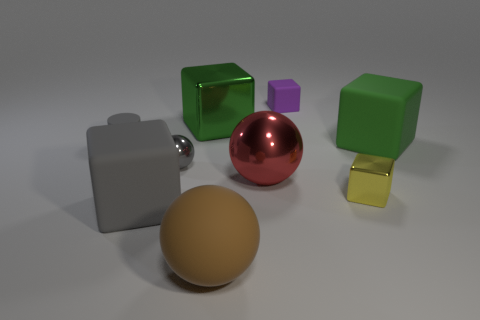There is a brown thing that is the same size as the gray rubber block; what is it made of?
Offer a terse response. Rubber. Is the number of small gray shiny objects to the right of the green matte thing less than the number of small rubber cylinders that are on the right side of the big shiny cube?
Give a very brief answer. No. There is a big shiny sphere; are there any tiny gray rubber things in front of it?
Give a very brief answer. No. There is a green thing that is right of the shiny block that is on the left side of the large rubber ball; is there a big metallic sphere on the left side of it?
Keep it short and to the point. Yes. There is a big shiny object that is behind the big red ball; is its shape the same as the small yellow metal object?
Keep it short and to the point. Yes. There is a tiny cylinder that is made of the same material as the purple block; what color is it?
Your answer should be very brief. Gray. How many gray things have the same material as the red sphere?
Your answer should be very brief. 1. There is a big metal object to the right of the big green thing that is on the left side of the ball in front of the small yellow cube; what color is it?
Offer a terse response. Red. Does the brown object have the same size as the gray metallic object?
Your response must be concise. No. Is there any other thing that is the same shape as the small yellow thing?
Provide a succinct answer. Yes. 